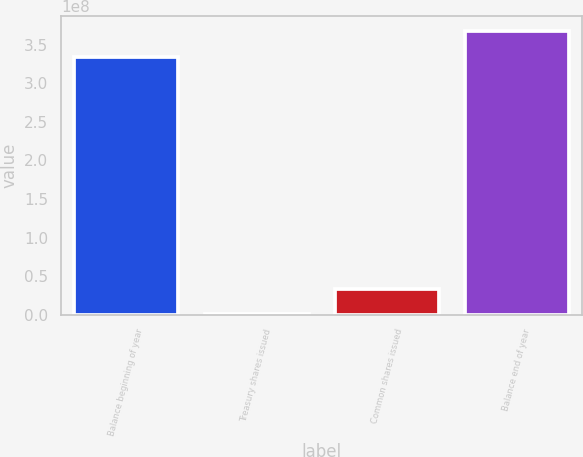Convert chart to OTSL. <chart><loc_0><loc_0><loc_500><loc_500><bar_chart><fcel>Balance beginning of year<fcel>Treasury shares issued<fcel>Common shares issued<fcel>Balance end of year<nl><fcel>3.3471e+08<fcel>404232<fcel>3.40075e+07<fcel>3.68313e+08<nl></chart> 